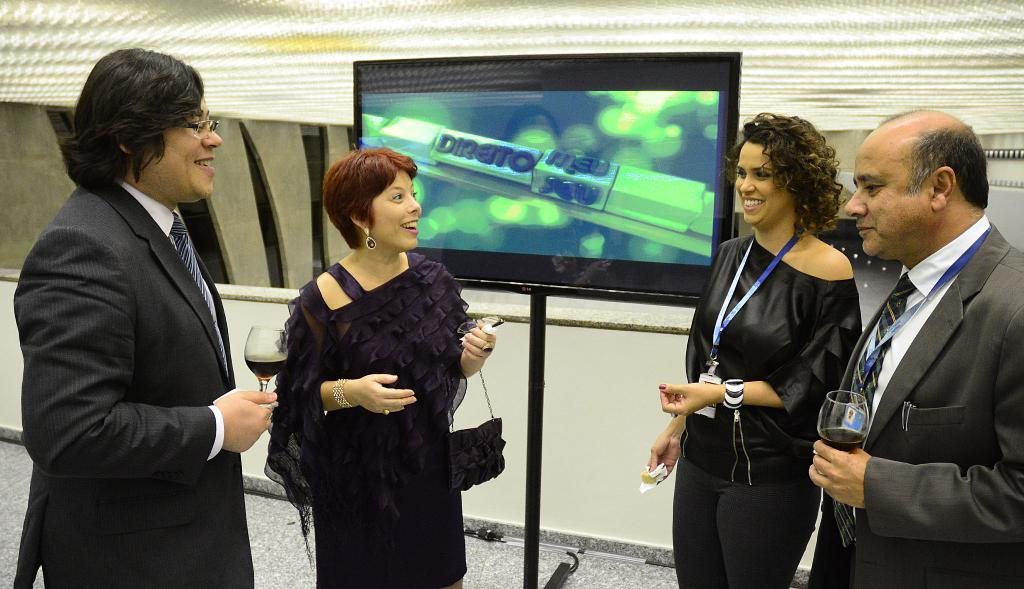What can be seen in the image involving people? There are people standing in the image. What type of object made of glass is present in the image? There is a glass object in the image. What is the bag used for in the image? The bag is present in the image, but its purpose is not specified. What electronic device is visible in the image? There is a television in the image. What type of structure can be seen in the background of the image? There is a wall in the image. What type of form does the kitten take in the image? There is no kitten present in the image. How many dimes are visible on the wall in the image? There are no dimes visible on the wall in the image. 